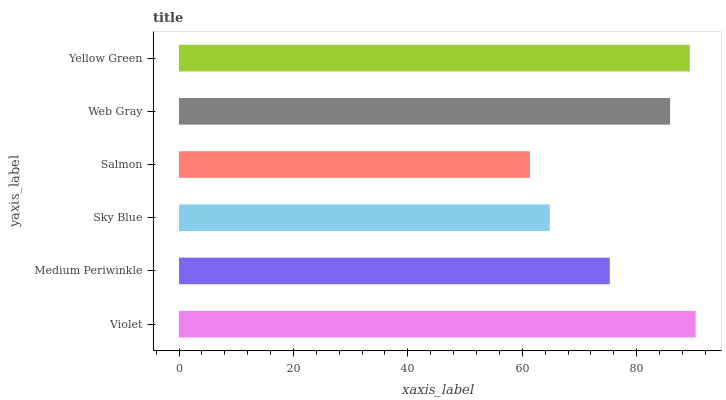Is Salmon the minimum?
Answer yes or no. Yes. Is Violet the maximum?
Answer yes or no. Yes. Is Medium Periwinkle the minimum?
Answer yes or no. No. Is Medium Periwinkle the maximum?
Answer yes or no. No. Is Violet greater than Medium Periwinkle?
Answer yes or no. Yes. Is Medium Periwinkle less than Violet?
Answer yes or no. Yes. Is Medium Periwinkle greater than Violet?
Answer yes or no. No. Is Violet less than Medium Periwinkle?
Answer yes or no. No. Is Web Gray the high median?
Answer yes or no. Yes. Is Medium Periwinkle the low median?
Answer yes or no. Yes. Is Salmon the high median?
Answer yes or no. No. Is Web Gray the low median?
Answer yes or no. No. 